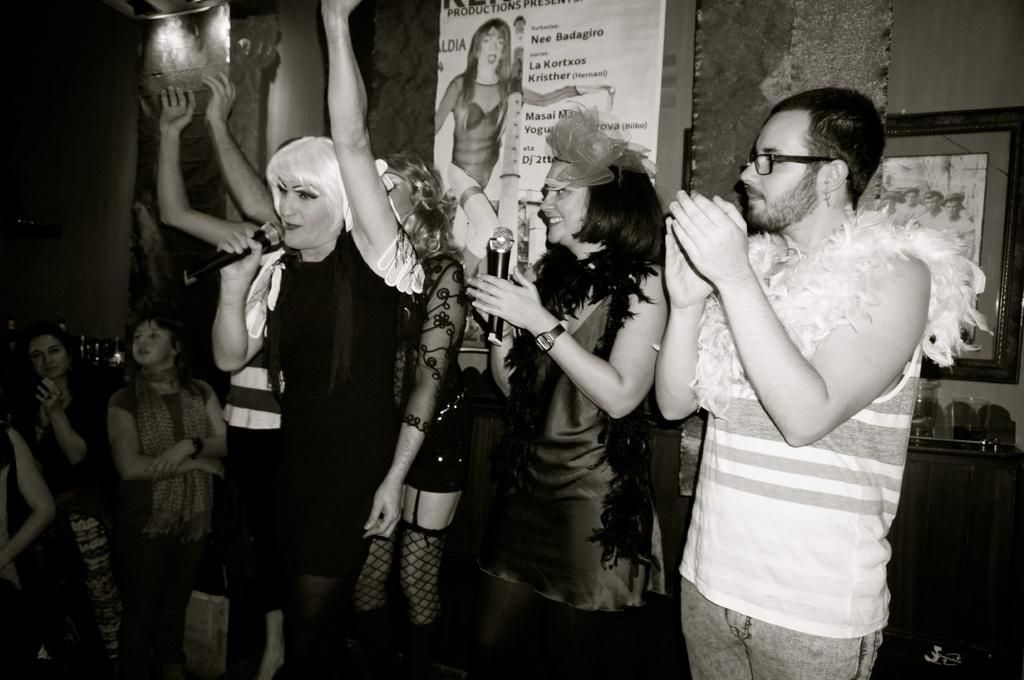How many people are in the group in the image? There is a group of people in the image, but the exact number is not specified. What are some people in the group doing? Some people in the group are holding microphones. What is the facial expression of the people holding microphones? The people holding microphones are smiling. What can be seen in the background of the image? There are banners, a wall, a photo frame, and other objects visible in the background of the image. What type of rock is being used as a seat by the people in the image? There is no rock present in the image; the people are standing or holding microphones. What color are the trousers worn by the people in the image? The provided facts do not mention the color or type of clothing worn by the people in the image. 